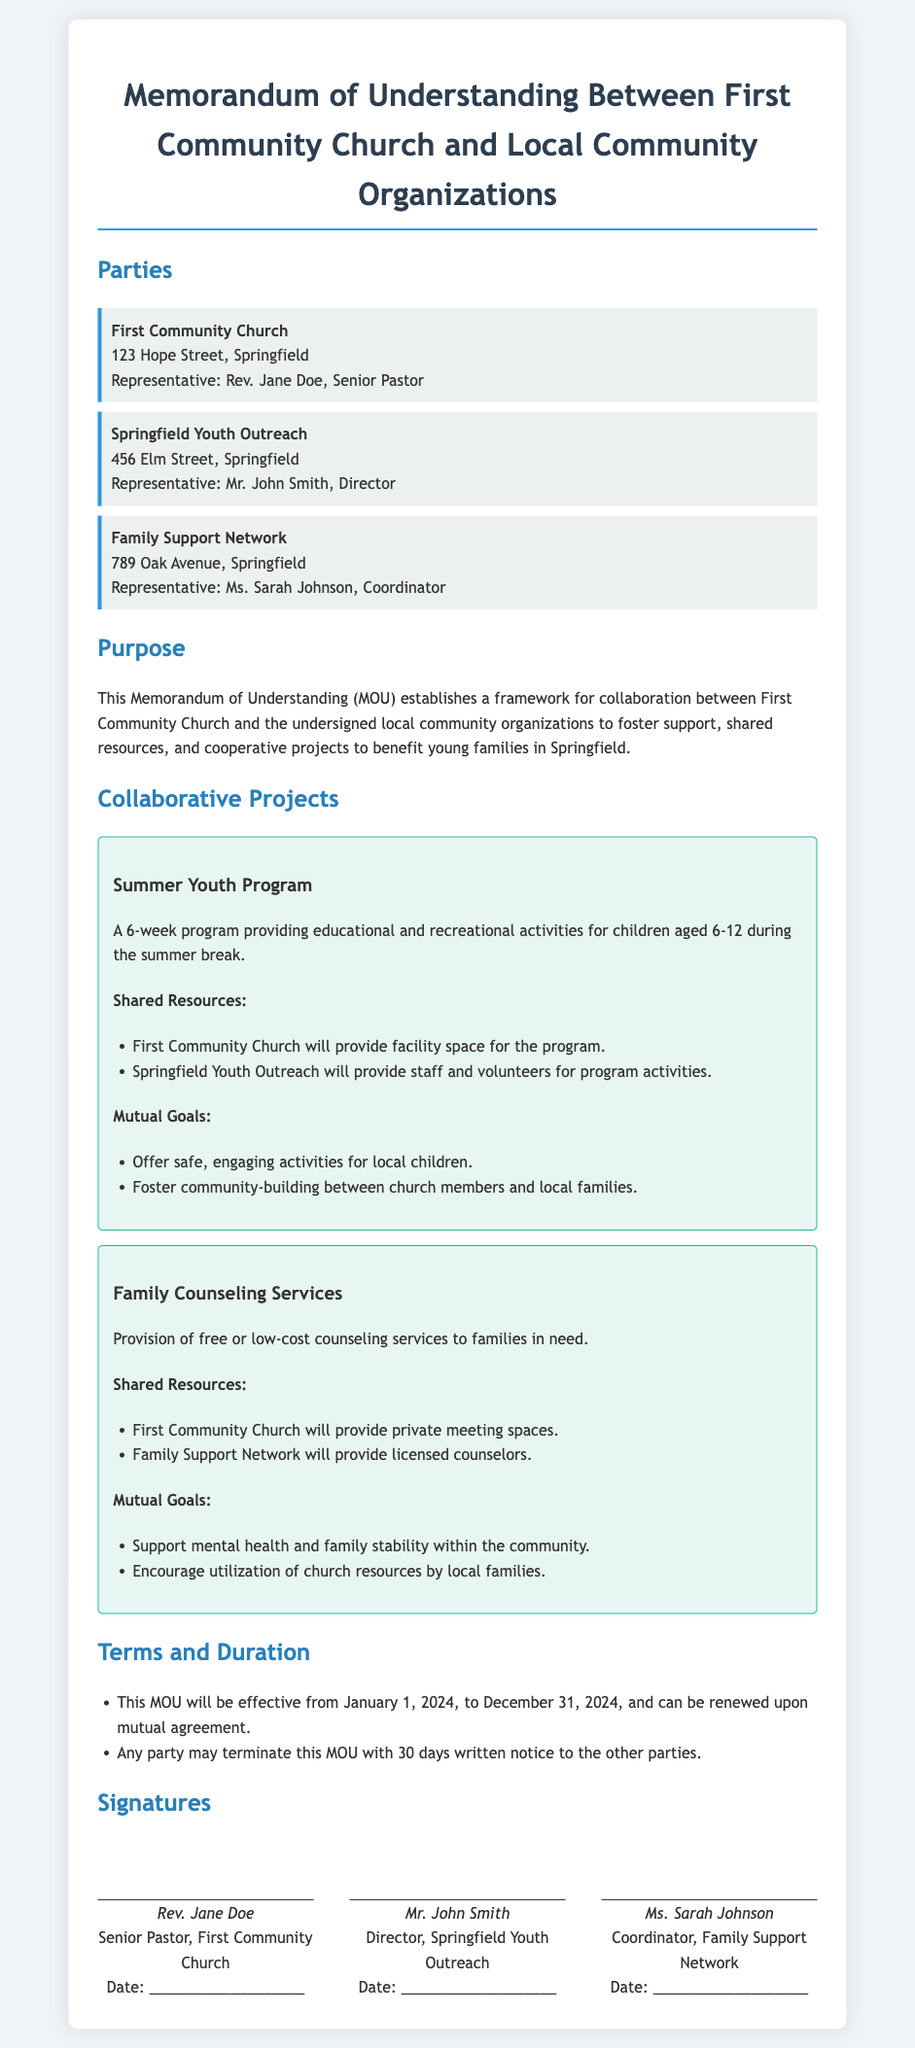What is the name of the church? The name of the church is mentioned in the document as the primary party of the MOU.
Answer: First Community Church Who is the representative of Springfield Youth Outreach? The representative of Springfield Youth Outreach is noted in the document under the party section.
Answer: Mr. John Smith What is the duration of the MOU? The duration is specified in the terms section of the document.
Answer: January 1, 2024, to December 31, 2024 What project involves providing educational activities during summer? The project name is found under the collaborative projects section.
Answer: Summer Youth Program What resource will Family Support Network provide? This information is present in the shared resources section of the Family Counseling Services project.
Answer: Licensed counselors What is a mutual goal of the Summer Youth Program? Mutual goals are listed for different projects within the document, directly answering this question.
Answer: Foster community-building between church members and local families How many days notice is required to terminate the MOU? This detail is included in the terms and duration section of the document.
Answer: 30 days What is the address of First Community Church? The address is specified in the parties section of the document.
Answer: 123 Hope Street, Springfield 